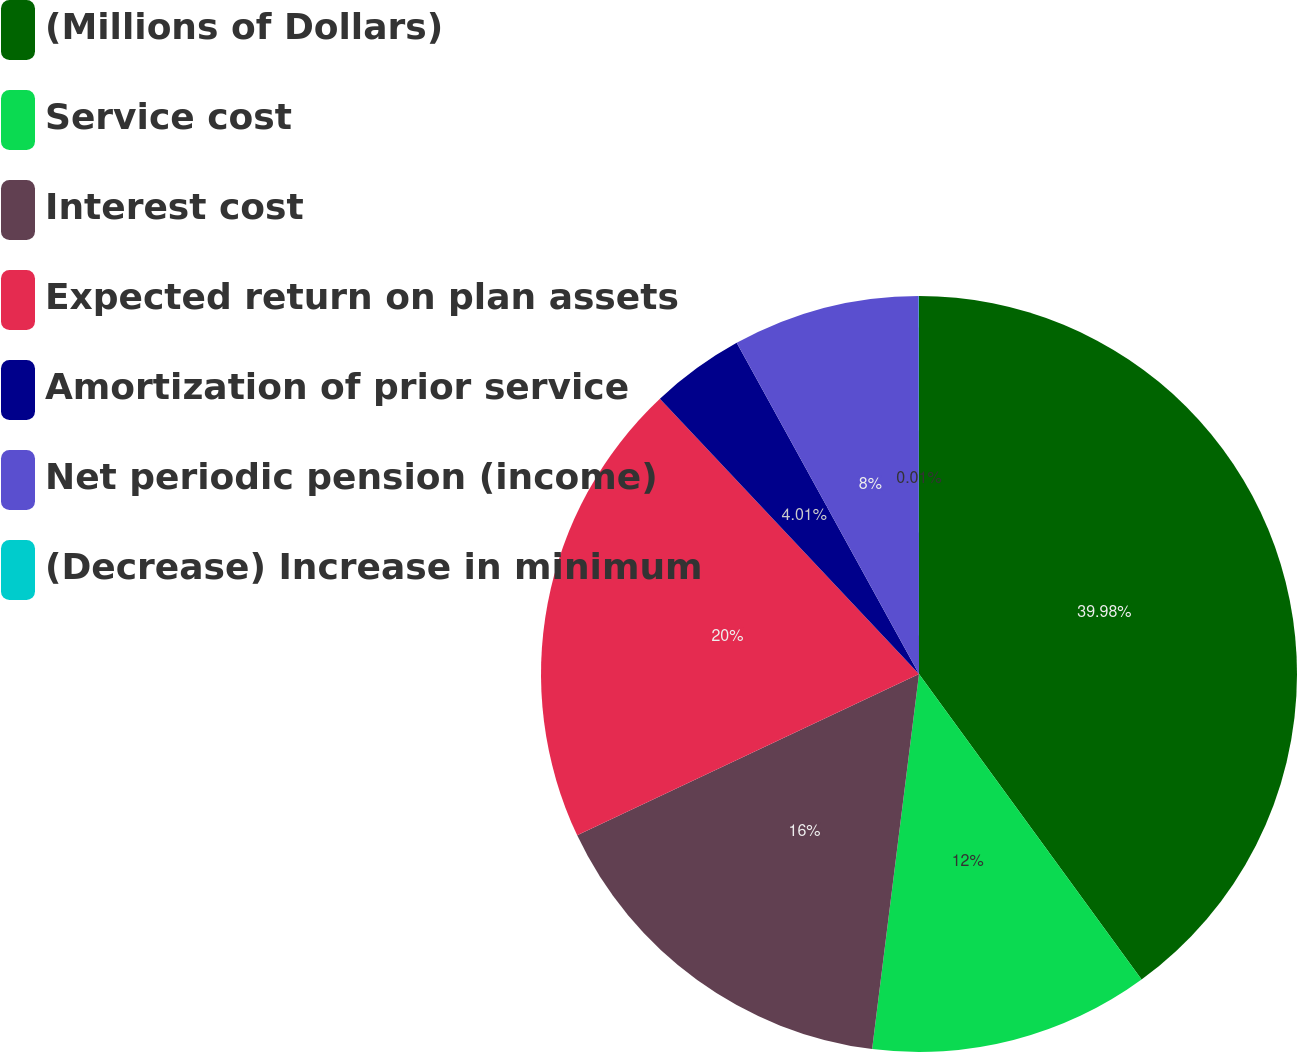<chart> <loc_0><loc_0><loc_500><loc_500><pie_chart><fcel>(Millions of Dollars)<fcel>Service cost<fcel>Interest cost<fcel>Expected return on plan assets<fcel>Amortization of prior service<fcel>Net periodic pension (income)<fcel>(Decrease) Increase in minimum<nl><fcel>39.98%<fcel>12.0%<fcel>16.0%<fcel>20.0%<fcel>4.01%<fcel>8.0%<fcel>0.01%<nl></chart> 